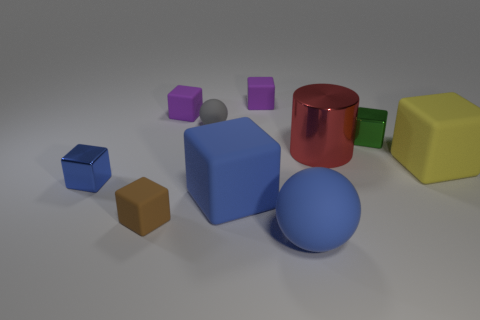Subtract 2 blocks. How many blocks are left? 5 Subtract all blue cubes. How many cubes are left? 5 Subtract all tiny green blocks. How many blocks are left? 6 Subtract all yellow cubes. Subtract all gray cylinders. How many cubes are left? 6 Subtract all cylinders. How many objects are left? 9 Add 9 big blue blocks. How many big blue blocks are left? 10 Add 1 tiny blue metallic blocks. How many tiny blue metallic blocks exist? 2 Subtract 1 brown blocks. How many objects are left? 9 Subtract all tiny green metal blocks. Subtract all green blocks. How many objects are left? 8 